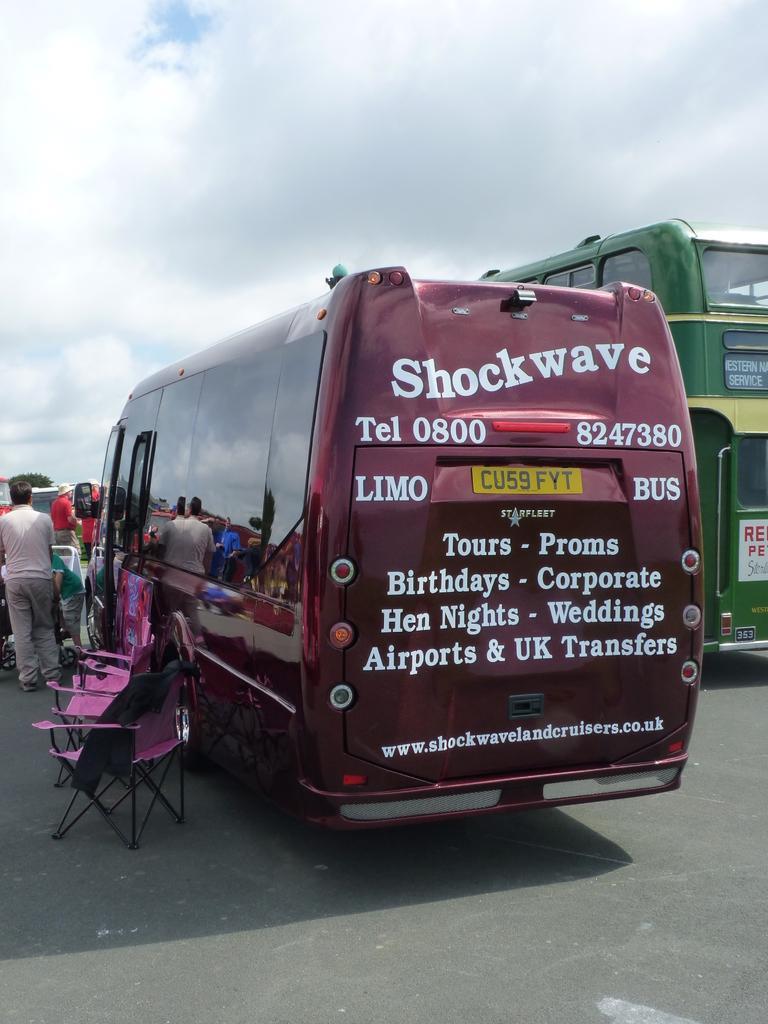Describe this image in one or two sentences. In this image I can see the ground, two buses which are maroon and green in color on the ground, few chairs and few persons standing. In the background I can see few trees and the sky. 